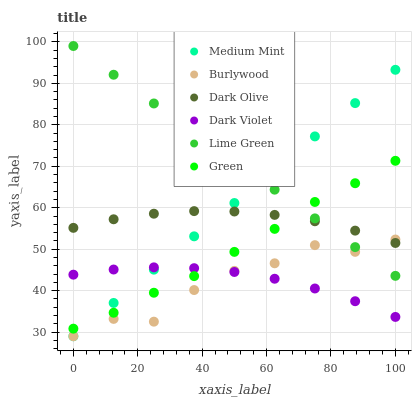Does Burlywood have the minimum area under the curve?
Answer yes or no. Yes. Does Lime Green have the maximum area under the curve?
Answer yes or no. Yes. Does Dark Olive have the minimum area under the curve?
Answer yes or no. No. Does Dark Olive have the maximum area under the curve?
Answer yes or no. No. Is Lime Green the smoothest?
Answer yes or no. Yes. Is Burlywood the roughest?
Answer yes or no. Yes. Is Dark Olive the smoothest?
Answer yes or no. No. Is Dark Olive the roughest?
Answer yes or no. No. Does Medium Mint have the lowest value?
Answer yes or no. Yes. Does Dark Olive have the lowest value?
Answer yes or no. No. Does Lime Green have the highest value?
Answer yes or no. Yes. Does Burlywood have the highest value?
Answer yes or no. No. Is Dark Violet less than Dark Olive?
Answer yes or no. Yes. Is Lime Green greater than Dark Violet?
Answer yes or no. Yes. Does Burlywood intersect Dark Olive?
Answer yes or no. Yes. Is Burlywood less than Dark Olive?
Answer yes or no. No. Is Burlywood greater than Dark Olive?
Answer yes or no. No. Does Dark Violet intersect Dark Olive?
Answer yes or no. No. 